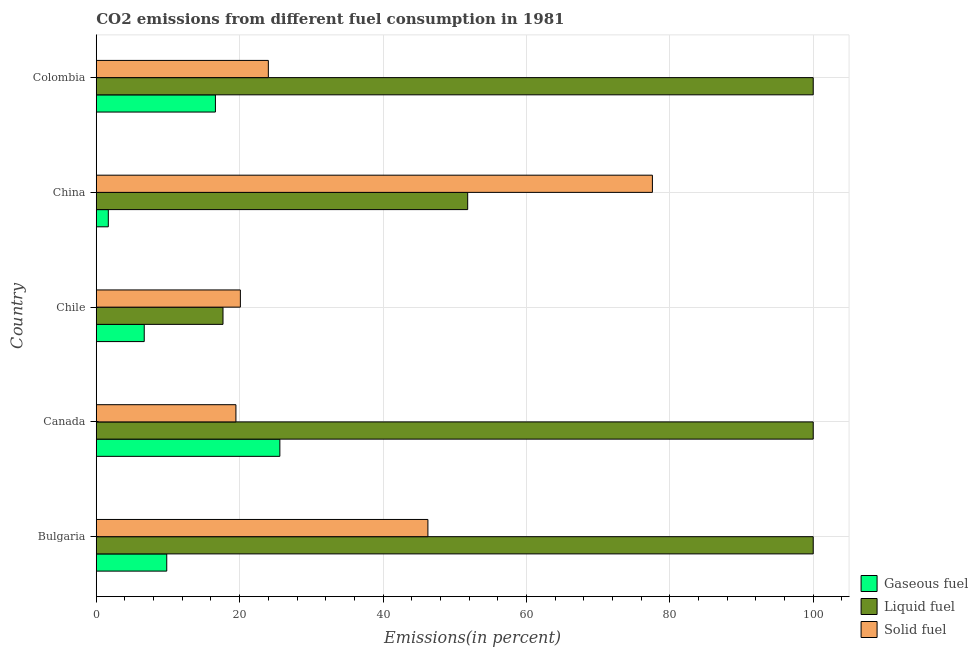How many bars are there on the 4th tick from the bottom?
Offer a terse response. 3. What is the percentage of liquid fuel emission in Canada?
Your answer should be compact. 100. Across all countries, what is the minimum percentage of liquid fuel emission?
Ensure brevity in your answer.  17.68. In which country was the percentage of solid fuel emission maximum?
Ensure brevity in your answer.  China. In which country was the percentage of liquid fuel emission minimum?
Keep it short and to the point. Chile. What is the total percentage of gaseous fuel emission in the graph?
Offer a very short reply. 60.43. What is the difference between the percentage of liquid fuel emission in Bulgaria and that in Colombia?
Ensure brevity in your answer.  0. What is the difference between the percentage of solid fuel emission in China and the percentage of gaseous fuel emission in Canada?
Provide a short and direct response. 51.96. What is the average percentage of gaseous fuel emission per country?
Keep it short and to the point. 12.09. What is the difference between the percentage of solid fuel emission and percentage of liquid fuel emission in Colombia?
Offer a very short reply. -76. What is the ratio of the percentage of solid fuel emission in Canada to that in China?
Keep it short and to the point. 0.25. What is the difference between the highest and the second highest percentage of gaseous fuel emission?
Provide a succinct answer. 8.99. What is the difference between the highest and the lowest percentage of liquid fuel emission?
Offer a very short reply. 82.32. What does the 3rd bar from the top in Colombia represents?
Offer a very short reply. Gaseous fuel. What does the 2nd bar from the bottom in Colombia represents?
Your answer should be very brief. Liquid fuel. Is it the case that in every country, the sum of the percentage of gaseous fuel emission and percentage of liquid fuel emission is greater than the percentage of solid fuel emission?
Ensure brevity in your answer.  No. Are all the bars in the graph horizontal?
Ensure brevity in your answer.  Yes. What is the difference between two consecutive major ticks on the X-axis?
Offer a terse response. 20. Are the values on the major ticks of X-axis written in scientific E-notation?
Your answer should be compact. No. Where does the legend appear in the graph?
Offer a terse response. Bottom right. How are the legend labels stacked?
Offer a very short reply. Vertical. What is the title of the graph?
Your answer should be very brief. CO2 emissions from different fuel consumption in 1981. Does "Liquid fuel" appear as one of the legend labels in the graph?
Make the answer very short. Yes. What is the label or title of the X-axis?
Provide a succinct answer. Emissions(in percent). What is the label or title of the Y-axis?
Offer a very short reply. Country. What is the Emissions(in percent) of Gaseous fuel in Bulgaria?
Offer a very short reply. 9.83. What is the Emissions(in percent) in Solid fuel in Bulgaria?
Provide a short and direct response. 46.26. What is the Emissions(in percent) of Gaseous fuel in Canada?
Your response must be concise. 25.61. What is the Emissions(in percent) in Solid fuel in Canada?
Keep it short and to the point. 19.48. What is the Emissions(in percent) in Gaseous fuel in Chile?
Offer a very short reply. 6.69. What is the Emissions(in percent) of Liquid fuel in Chile?
Provide a short and direct response. 17.68. What is the Emissions(in percent) in Solid fuel in Chile?
Keep it short and to the point. 20.1. What is the Emissions(in percent) of Gaseous fuel in China?
Give a very brief answer. 1.68. What is the Emissions(in percent) of Liquid fuel in China?
Give a very brief answer. 51.81. What is the Emissions(in percent) in Solid fuel in China?
Offer a terse response. 77.57. What is the Emissions(in percent) in Gaseous fuel in Colombia?
Provide a succinct answer. 16.62. What is the Emissions(in percent) in Liquid fuel in Colombia?
Keep it short and to the point. 100. What is the Emissions(in percent) in Solid fuel in Colombia?
Provide a short and direct response. 24. Across all countries, what is the maximum Emissions(in percent) in Gaseous fuel?
Keep it short and to the point. 25.61. Across all countries, what is the maximum Emissions(in percent) of Liquid fuel?
Make the answer very short. 100. Across all countries, what is the maximum Emissions(in percent) in Solid fuel?
Your answer should be very brief. 77.57. Across all countries, what is the minimum Emissions(in percent) in Gaseous fuel?
Provide a short and direct response. 1.68. Across all countries, what is the minimum Emissions(in percent) of Liquid fuel?
Offer a terse response. 17.68. Across all countries, what is the minimum Emissions(in percent) in Solid fuel?
Provide a succinct answer. 19.48. What is the total Emissions(in percent) in Gaseous fuel in the graph?
Your answer should be compact. 60.43. What is the total Emissions(in percent) of Liquid fuel in the graph?
Your answer should be compact. 369.48. What is the total Emissions(in percent) in Solid fuel in the graph?
Offer a very short reply. 187.41. What is the difference between the Emissions(in percent) of Gaseous fuel in Bulgaria and that in Canada?
Keep it short and to the point. -15.78. What is the difference between the Emissions(in percent) of Liquid fuel in Bulgaria and that in Canada?
Keep it short and to the point. 0. What is the difference between the Emissions(in percent) of Solid fuel in Bulgaria and that in Canada?
Offer a terse response. 26.78. What is the difference between the Emissions(in percent) in Gaseous fuel in Bulgaria and that in Chile?
Offer a terse response. 3.14. What is the difference between the Emissions(in percent) in Liquid fuel in Bulgaria and that in Chile?
Keep it short and to the point. 82.32. What is the difference between the Emissions(in percent) of Solid fuel in Bulgaria and that in Chile?
Make the answer very short. 26.16. What is the difference between the Emissions(in percent) in Gaseous fuel in Bulgaria and that in China?
Provide a short and direct response. 8.15. What is the difference between the Emissions(in percent) of Liquid fuel in Bulgaria and that in China?
Keep it short and to the point. 48.19. What is the difference between the Emissions(in percent) in Solid fuel in Bulgaria and that in China?
Your answer should be compact. -31.31. What is the difference between the Emissions(in percent) of Gaseous fuel in Bulgaria and that in Colombia?
Your answer should be compact. -6.79. What is the difference between the Emissions(in percent) in Solid fuel in Bulgaria and that in Colombia?
Your answer should be compact. 22.26. What is the difference between the Emissions(in percent) in Gaseous fuel in Canada and that in Chile?
Ensure brevity in your answer.  18.92. What is the difference between the Emissions(in percent) of Liquid fuel in Canada and that in Chile?
Provide a short and direct response. 82.32. What is the difference between the Emissions(in percent) of Solid fuel in Canada and that in Chile?
Ensure brevity in your answer.  -0.62. What is the difference between the Emissions(in percent) in Gaseous fuel in Canada and that in China?
Provide a succinct answer. 23.93. What is the difference between the Emissions(in percent) of Liquid fuel in Canada and that in China?
Your answer should be compact. 48.19. What is the difference between the Emissions(in percent) of Solid fuel in Canada and that in China?
Offer a terse response. -58.09. What is the difference between the Emissions(in percent) of Gaseous fuel in Canada and that in Colombia?
Provide a short and direct response. 8.99. What is the difference between the Emissions(in percent) of Solid fuel in Canada and that in Colombia?
Give a very brief answer. -4.52. What is the difference between the Emissions(in percent) of Gaseous fuel in Chile and that in China?
Offer a terse response. 5.01. What is the difference between the Emissions(in percent) of Liquid fuel in Chile and that in China?
Provide a succinct answer. -34.13. What is the difference between the Emissions(in percent) in Solid fuel in Chile and that in China?
Offer a very short reply. -57.47. What is the difference between the Emissions(in percent) in Gaseous fuel in Chile and that in Colombia?
Make the answer very short. -9.93. What is the difference between the Emissions(in percent) in Liquid fuel in Chile and that in Colombia?
Offer a very short reply. -82.32. What is the difference between the Emissions(in percent) in Solid fuel in Chile and that in Colombia?
Your answer should be compact. -3.9. What is the difference between the Emissions(in percent) in Gaseous fuel in China and that in Colombia?
Your answer should be compact. -14.94. What is the difference between the Emissions(in percent) of Liquid fuel in China and that in Colombia?
Your answer should be compact. -48.19. What is the difference between the Emissions(in percent) in Solid fuel in China and that in Colombia?
Your answer should be compact. 53.57. What is the difference between the Emissions(in percent) of Gaseous fuel in Bulgaria and the Emissions(in percent) of Liquid fuel in Canada?
Your response must be concise. -90.17. What is the difference between the Emissions(in percent) of Gaseous fuel in Bulgaria and the Emissions(in percent) of Solid fuel in Canada?
Your answer should be compact. -9.65. What is the difference between the Emissions(in percent) in Liquid fuel in Bulgaria and the Emissions(in percent) in Solid fuel in Canada?
Your answer should be very brief. 80.52. What is the difference between the Emissions(in percent) of Gaseous fuel in Bulgaria and the Emissions(in percent) of Liquid fuel in Chile?
Offer a terse response. -7.85. What is the difference between the Emissions(in percent) in Gaseous fuel in Bulgaria and the Emissions(in percent) in Solid fuel in Chile?
Offer a terse response. -10.27. What is the difference between the Emissions(in percent) of Liquid fuel in Bulgaria and the Emissions(in percent) of Solid fuel in Chile?
Offer a very short reply. 79.9. What is the difference between the Emissions(in percent) of Gaseous fuel in Bulgaria and the Emissions(in percent) of Liquid fuel in China?
Your answer should be compact. -41.98. What is the difference between the Emissions(in percent) of Gaseous fuel in Bulgaria and the Emissions(in percent) of Solid fuel in China?
Provide a short and direct response. -67.74. What is the difference between the Emissions(in percent) of Liquid fuel in Bulgaria and the Emissions(in percent) of Solid fuel in China?
Offer a terse response. 22.43. What is the difference between the Emissions(in percent) in Gaseous fuel in Bulgaria and the Emissions(in percent) in Liquid fuel in Colombia?
Provide a succinct answer. -90.17. What is the difference between the Emissions(in percent) of Gaseous fuel in Bulgaria and the Emissions(in percent) of Solid fuel in Colombia?
Your answer should be very brief. -14.17. What is the difference between the Emissions(in percent) in Liquid fuel in Bulgaria and the Emissions(in percent) in Solid fuel in Colombia?
Offer a terse response. 76. What is the difference between the Emissions(in percent) of Gaseous fuel in Canada and the Emissions(in percent) of Liquid fuel in Chile?
Offer a terse response. 7.93. What is the difference between the Emissions(in percent) of Gaseous fuel in Canada and the Emissions(in percent) of Solid fuel in Chile?
Provide a succinct answer. 5.51. What is the difference between the Emissions(in percent) in Liquid fuel in Canada and the Emissions(in percent) in Solid fuel in Chile?
Provide a short and direct response. 79.9. What is the difference between the Emissions(in percent) in Gaseous fuel in Canada and the Emissions(in percent) in Liquid fuel in China?
Make the answer very short. -26.2. What is the difference between the Emissions(in percent) of Gaseous fuel in Canada and the Emissions(in percent) of Solid fuel in China?
Offer a terse response. -51.96. What is the difference between the Emissions(in percent) in Liquid fuel in Canada and the Emissions(in percent) in Solid fuel in China?
Give a very brief answer. 22.43. What is the difference between the Emissions(in percent) in Gaseous fuel in Canada and the Emissions(in percent) in Liquid fuel in Colombia?
Offer a very short reply. -74.39. What is the difference between the Emissions(in percent) of Gaseous fuel in Canada and the Emissions(in percent) of Solid fuel in Colombia?
Give a very brief answer. 1.61. What is the difference between the Emissions(in percent) in Liquid fuel in Canada and the Emissions(in percent) in Solid fuel in Colombia?
Provide a succinct answer. 76. What is the difference between the Emissions(in percent) of Gaseous fuel in Chile and the Emissions(in percent) of Liquid fuel in China?
Provide a short and direct response. -45.12. What is the difference between the Emissions(in percent) in Gaseous fuel in Chile and the Emissions(in percent) in Solid fuel in China?
Your answer should be compact. -70.88. What is the difference between the Emissions(in percent) in Liquid fuel in Chile and the Emissions(in percent) in Solid fuel in China?
Provide a succinct answer. -59.89. What is the difference between the Emissions(in percent) of Gaseous fuel in Chile and the Emissions(in percent) of Liquid fuel in Colombia?
Make the answer very short. -93.31. What is the difference between the Emissions(in percent) in Gaseous fuel in Chile and the Emissions(in percent) in Solid fuel in Colombia?
Your answer should be compact. -17.31. What is the difference between the Emissions(in percent) in Liquid fuel in Chile and the Emissions(in percent) in Solid fuel in Colombia?
Your answer should be compact. -6.32. What is the difference between the Emissions(in percent) of Gaseous fuel in China and the Emissions(in percent) of Liquid fuel in Colombia?
Your answer should be compact. -98.32. What is the difference between the Emissions(in percent) of Gaseous fuel in China and the Emissions(in percent) of Solid fuel in Colombia?
Provide a short and direct response. -22.32. What is the difference between the Emissions(in percent) of Liquid fuel in China and the Emissions(in percent) of Solid fuel in Colombia?
Give a very brief answer. 27.8. What is the average Emissions(in percent) in Gaseous fuel per country?
Your response must be concise. 12.09. What is the average Emissions(in percent) in Liquid fuel per country?
Your answer should be compact. 73.9. What is the average Emissions(in percent) in Solid fuel per country?
Ensure brevity in your answer.  37.48. What is the difference between the Emissions(in percent) of Gaseous fuel and Emissions(in percent) of Liquid fuel in Bulgaria?
Keep it short and to the point. -90.17. What is the difference between the Emissions(in percent) of Gaseous fuel and Emissions(in percent) of Solid fuel in Bulgaria?
Give a very brief answer. -36.43. What is the difference between the Emissions(in percent) of Liquid fuel and Emissions(in percent) of Solid fuel in Bulgaria?
Offer a terse response. 53.74. What is the difference between the Emissions(in percent) of Gaseous fuel and Emissions(in percent) of Liquid fuel in Canada?
Your answer should be very brief. -74.39. What is the difference between the Emissions(in percent) of Gaseous fuel and Emissions(in percent) of Solid fuel in Canada?
Offer a terse response. 6.13. What is the difference between the Emissions(in percent) in Liquid fuel and Emissions(in percent) in Solid fuel in Canada?
Keep it short and to the point. 80.52. What is the difference between the Emissions(in percent) in Gaseous fuel and Emissions(in percent) in Liquid fuel in Chile?
Your answer should be compact. -10.99. What is the difference between the Emissions(in percent) of Gaseous fuel and Emissions(in percent) of Solid fuel in Chile?
Your answer should be compact. -13.41. What is the difference between the Emissions(in percent) in Liquid fuel and Emissions(in percent) in Solid fuel in Chile?
Provide a short and direct response. -2.42. What is the difference between the Emissions(in percent) of Gaseous fuel and Emissions(in percent) of Liquid fuel in China?
Offer a terse response. -50.12. What is the difference between the Emissions(in percent) of Gaseous fuel and Emissions(in percent) of Solid fuel in China?
Your answer should be very brief. -75.89. What is the difference between the Emissions(in percent) of Liquid fuel and Emissions(in percent) of Solid fuel in China?
Make the answer very short. -25.76. What is the difference between the Emissions(in percent) in Gaseous fuel and Emissions(in percent) in Liquid fuel in Colombia?
Offer a terse response. -83.38. What is the difference between the Emissions(in percent) in Gaseous fuel and Emissions(in percent) in Solid fuel in Colombia?
Provide a short and direct response. -7.38. What is the difference between the Emissions(in percent) in Liquid fuel and Emissions(in percent) in Solid fuel in Colombia?
Keep it short and to the point. 76. What is the ratio of the Emissions(in percent) of Gaseous fuel in Bulgaria to that in Canada?
Provide a short and direct response. 0.38. What is the ratio of the Emissions(in percent) of Solid fuel in Bulgaria to that in Canada?
Your answer should be compact. 2.37. What is the ratio of the Emissions(in percent) of Gaseous fuel in Bulgaria to that in Chile?
Give a very brief answer. 1.47. What is the ratio of the Emissions(in percent) of Liquid fuel in Bulgaria to that in Chile?
Ensure brevity in your answer.  5.66. What is the ratio of the Emissions(in percent) of Solid fuel in Bulgaria to that in Chile?
Ensure brevity in your answer.  2.3. What is the ratio of the Emissions(in percent) of Gaseous fuel in Bulgaria to that in China?
Make the answer very short. 5.85. What is the ratio of the Emissions(in percent) of Liquid fuel in Bulgaria to that in China?
Offer a very short reply. 1.93. What is the ratio of the Emissions(in percent) of Solid fuel in Bulgaria to that in China?
Offer a very short reply. 0.6. What is the ratio of the Emissions(in percent) of Gaseous fuel in Bulgaria to that in Colombia?
Provide a succinct answer. 0.59. What is the ratio of the Emissions(in percent) in Liquid fuel in Bulgaria to that in Colombia?
Provide a short and direct response. 1. What is the ratio of the Emissions(in percent) of Solid fuel in Bulgaria to that in Colombia?
Give a very brief answer. 1.93. What is the ratio of the Emissions(in percent) in Gaseous fuel in Canada to that in Chile?
Keep it short and to the point. 3.83. What is the ratio of the Emissions(in percent) in Liquid fuel in Canada to that in Chile?
Provide a succinct answer. 5.66. What is the ratio of the Emissions(in percent) of Solid fuel in Canada to that in Chile?
Offer a terse response. 0.97. What is the ratio of the Emissions(in percent) in Gaseous fuel in Canada to that in China?
Provide a succinct answer. 15.23. What is the ratio of the Emissions(in percent) in Liquid fuel in Canada to that in China?
Provide a short and direct response. 1.93. What is the ratio of the Emissions(in percent) in Solid fuel in Canada to that in China?
Offer a terse response. 0.25. What is the ratio of the Emissions(in percent) in Gaseous fuel in Canada to that in Colombia?
Keep it short and to the point. 1.54. What is the ratio of the Emissions(in percent) in Solid fuel in Canada to that in Colombia?
Your answer should be compact. 0.81. What is the ratio of the Emissions(in percent) in Gaseous fuel in Chile to that in China?
Ensure brevity in your answer.  3.98. What is the ratio of the Emissions(in percent) of Liquid fuel in Chile to that in China?
Offer a very short reply. 0.34. What is the ratio of the Emissions(in percent) in Solid fuel in Chile to that in China?
Make the answer very short. 0.26. What is the ratio of the Emissions(in percent) of Gaseous fuel in Chile to that in Colombia?
Provide a succinct answer. 0.4. What is the ratio of the Emissions(in percent) of Liquid fuel in Chile to that in Colombia?
Offer a very short reply. 0.18. What is the ratio of the Emissions(in percent) of Solid fuel in Chile to that in Colombia?
Make the answer very short. 0.84. What is the ratio of the Emissions(in percent) in Gaseous fuel in China to that in Colombia?
Make the answer very short. 0.1. What is the ratio of the Emissions(in percent) of Liquid fuel in China to that in Colombia?
Provide a succinct answer. 0.52. What is the ratio of the Emissions(in percent) in Solid fuel in China to that in Colombia?
Offer a terse response. 3.23. What is the difference between the highest and the second highest Emissions(in percent) in Gaseous fuel?
Ensure brevity in your answer.  8.99. What is the difference between the highest and the second highest Emissions(in percent) of Liquid fuel?
Provide a succinct answer. 0. What is the difference between the highest and the second highest Emissions(in percent) of Solid fuel?
Make the answer very short. 31.31. What is the difference between the highest and the lowest Emissions(in percent) in Gaseous fuel?
Provide a short and direct response. 23.93. What is the difference between the highest and the lowest Emissions(in percent) of Liquid fuel?
Offer a terse response. 82.32. What is the difference between the highest and the lowest Emissions(in percent) of Solid fuel?
Offer a very short reply. 58.09. 